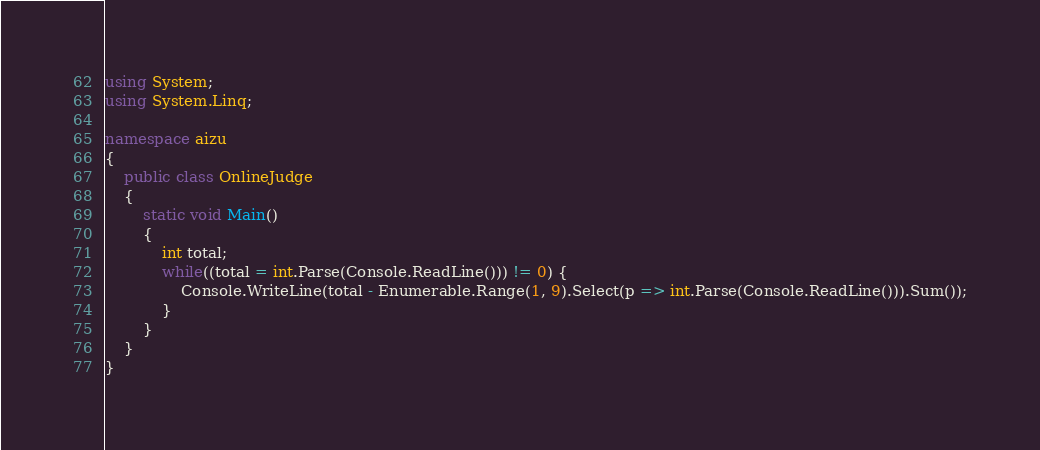Convert code to text. <code><loc_0><loc_0><loc_500><loc_500><_C#_>using System;
using System.Linq;

namespace aizu
{
    public class OnlineJudge
    {
        static void Main()
        {
            int total;
            while((total = int.Parse(Console.ReadLine())) != 0) {
                Console.WriteLine(total - Enumerable.Range(1, 9).Select(p => int.Parse(Console.ReadLine())).Sum());
            }
        }
    }
}</code> 